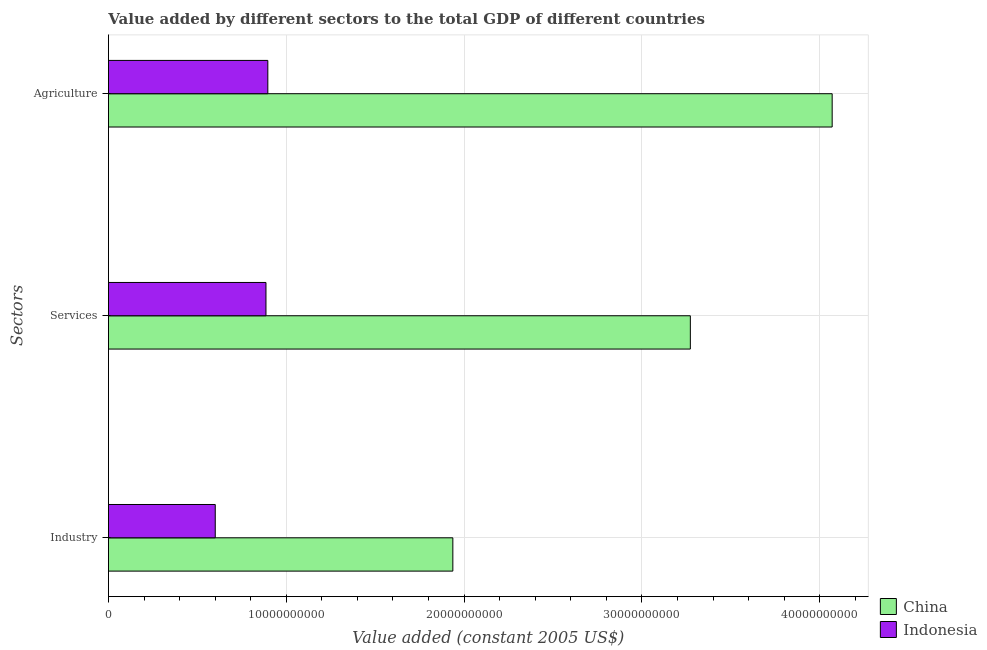How many different coloured bars are there?
Provide a short and direct response. 2. Are the number of bars per tick equal to the number of legend labels?
Your answer should be compact. Yes. How many bars are there on the 1st tick from the top?
Provide a short and direct response. 2. What is the label of the 3rd group of bars from the top?
Provide a succinct answer. Industry. What is the value added by industrial sector in Indonesia?
Make the answer very short. 6.01e+09. Across all countries, what is the maximum value added by services?
Your response must be concise. 3.27e+1. Across all countries, what is the minimum value added by industrial sector?
Make the answer very short. 6.01e+09. In which country was the value added by industrial sector maximum?
Your answer should be very brief. China. What is the total value added by services in the graph?
Your response must be concise. 4.16e+1. What is the difference between the value added by services in Indonesia and that in China?
Your answer should be compact. -2.39e+1. What is the difference between the value added by agricultural sector in Indonesia and the value added by services in China?
Offer a terse response. -2.38e+1. What is the average value added by agricultural sector per country?
Your answer should be compact. 2.48e+1. What is the difference between the value added by services and value added by agricultural sector in Indonesia?
Make the answer very short. -1.05e+08. In how many countries, is the value added by services greater than 12000000000 US$?
Give a very brief answer. 1. What is the ratio of the value added by services in Indonesia to that in China?
Ensure brevity in your answer.  0.27. What is the difference between the highest and the second highest value added by services?
Provide a short and direct response. 2.39e+1. What is the difference between the highest and the lowest value added by industrial sector?
Provide a succinct answer. 1.34e+1. Is the sum of the value added by agricultural sector in Indonesia and China greater than the maximum value added by services across all countries?
Offer a terse response. Yes. Is it the case that in every country, the sum of the value added by industrial sector and value added by services is greater than the value added by agricultural sector?
Provide a short and direct response. Yes. How many bars are there?
Offer a very short reply. 6. Are all the bars in the graph horizontal?
Your answer should be compact. Yes. How many countries are there in the graph?
Make the answer very short. 2. Are the values on the major ticks of X-axis written in scientific E-notation?
Your answer should be compact. No. Where does the legend appear in the graph?
Ensure brevity in your answer.  Bottom right. How many legend labels are there?
Your answer should be very brief. 2. How are the legend labels stacked?
Your response must be concise. Vertical. What is the title of the graph?
Ensure brevity in your answer.  Value added by different sectors to the total GDP of different countries. Does "Faeroe Islands" appear as one of the legend labels in the graph?
Your answer should be compact. No. What is the label or title of the X-axis?
Offer a very short reply. Value added (constant 2005 US$). What is the label or title of the Y-axis?
Keep it short and to the point. Sectors. What is the Value added (constant 2005 US$) in China in Industry?
Your answer should be compact. 1.94e+1. What is the Value added (constant 2005 US$) of Indonesia in Industry?
Keep it short and to the point. 6.01e+09. What is the Value added (constant 2005 US$) in China in Services?
Ensure brevity in your answer.  3.27e+1. What is the Value added (constant 2005 US$) in Indonesia in Services?
Offer a terse response. 8.86e+09. What is the Value added (constant 2005 US$) of China in Agriculture?
Offer a terse response. 4.07e+1. What is the Value added (constant 2005 US$) of Indonesia in Agriculture?
Your answer should be very brief. 8.96e+09. Across all Sectors, what is the maximum Value added (constant 2005 US$) of China?
Your answer should be compact. 4.07e+1. Across all Sectors, what is the maximum Value added (constant 2005 US$) in Indonesia?
Give a very brief answer. 8.96e+09. Across all Sectors, what is the minimum Value added (constant 2005 US$) in China?
Offer a terse response. 1.94e+1. Across all Sectors, what is the minimum Value added (constant 2005 US$) of Indonesia?
Give a very brief answer. 6.01e+09. What is the total Value added (constant 2005 US$) of China in the graph?
Offer a terse response. 9.28e+1. What is the total Value added (constant 2005 US$) in Indonesia in the graph?
Ensure brevity in your answer.  2.38e+1. What is the difference between the Value added (constant 2005 US$) of China in Industry and that in Services?
Your answer should be compact. -1.34e+1. What is the difference between the Value added (constant 2005 US$) in Indonesia in Industry and that in Services?
Your answer should be compact. -2.85e+09. What is the difference between the Value added (constant 2005 US$) of China in Industry and that in Agriculture?
Your answer should be compact. -2.13e+1. What is the difference between the Value added (constant 2005 US$) in Indonesia in Industry and that in Agriculture?
Give a very brief answer. -2.96e+09. What is the difference between the Value added (constant 2005 US$) of China in Services and that in Agriculture?
Give a very brief answer. -7.98e+09. What is the difference between the Value added (constant 2005 US$) of Indonesia in Services and that in Agriculture?
Your answer should be compact. -1.05e+08. What is the difference between the Value added (constant 2005 US$) of China in Industry and the Value added (constant 2005 US$) of Indonesia in Services?
Give a very brief answer. 1.05e+1. What is the difference between the Value added (constant 2005 US$) of China in Industry and the Value added (constant 2005 US$) of Indonesia in Agriculture?
Your answer should be very brief. 1.04e+1. What is the difference between the Value added (constant 2005 US$) of China in Services and the Value added (constant 2005 US$) of Indonesia in Agriculture?
Offer a terse response. 2.38e+1. What is the average Value added (constant 2005 US$) of China per Sectors?
Provide a short and direct response. 3.09e+1. What is the average Value added (constant 2005 US$) in Indonesia per Sectors?
Your answer should be very brief. 7.94e+09. What is the difference between the Value added (constant 2005 US$) of China and Value added (constant 2005 US$) of Indonesia in Industry?
Your response must be concise. 1.34e+1. What is the difference between the Value added (constant 2005 US$) of China and Value added (constant 2005 US$) of Indonesia in Services?
Your answer should be compact. 2.39e+1. What is the difference between the Value added (constant 2005 US$) of China and Value added (constant 2005 US$) of Indonesia in Agriculture?
Offer a terse response. 3.17e+1. What is the ratio of the Value added (constant 2005 US$) of China in Industry to that in Services?
Give a very brief answer. 0.59. What is the ratio of the Value added (constant 2005 US$) of Indonesia in Industry to that in Services?
Your response must be concise. 0.68. What is the ratio of the Value added (constant 2005 US$) in China in Industry to that in Agriculture?
Ensure brevity in your answer.  0.48. What is the ratio of the Value added (constant 2005 US$) of Indonesia in Industry to that in Agriculture?
Provide a succinct answer. 0.67. What is the ratio of the Value added (constant 2005 US$) of China in Services to that in Agriculture?
Offer a terse response. 0.8. What is the ratio of the Value added (constant 2005 US$) of Indonesia in Services to that in Agriculture?
Your response must be concise. 0.99. What is the difference between the highest and the second highest Value added (constant 2005 US$) in China?
Offer a terse response. 7.98e+09. What is the difference between the highest and the second highest Value added (constant 2005 US$) of Indonesia?
Keep it short and to the point. 1.05e+08. What is the difference between the highest and the lowest Value added (constant 2005 US$) in China?
Offer a very short reply. 2.13e+1. What is the difference between the highest and the lowest Value added (constant 2005 US$) in Indonesia?
Your answer should be compact. 2.96e+09. 